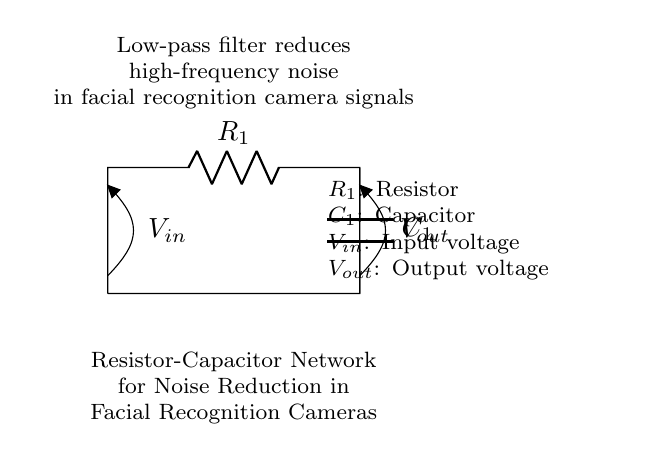What are the components in this circuit? The circuit contains a resistor and a capacitor, which are labeled as R1 and C1, respectively. These components are essential for filtering noise in the circuit.
Answer: Resistor, Capacitor What type of filter is represented by this circuit? The arrangement of the resistor and capacitor acts as a low-pass filter, designed to allow low-frequency signals to pass while attenuating high-frequency noise.
Answer: Low-pass filter What is the purpose of the resistor in this circuit? The resistor, designated as R1, helps limit the current flowing through the circuit and works in conjunction with the capacitor to set the cutoff frequency of the low-pass filter.
Answer: Limit current What happens to high-frequency noise in this circuit? High-frequency noise is attenuated by the capacitor in conjunction with the resistor, which allows only lower frequency signals to pass through effectively, filtering out noise that could interfere with facial recognition.
Answer: Attenuated What is the relationship between the input and output voltage in this circuit? The output voltage, represented as Vout, is lower than the input voltage, Vin, especially for high-frequency signals, due to the resistance and capacitive reactance that creates a voltage drop across the components.
Answer: Vout < Vin 